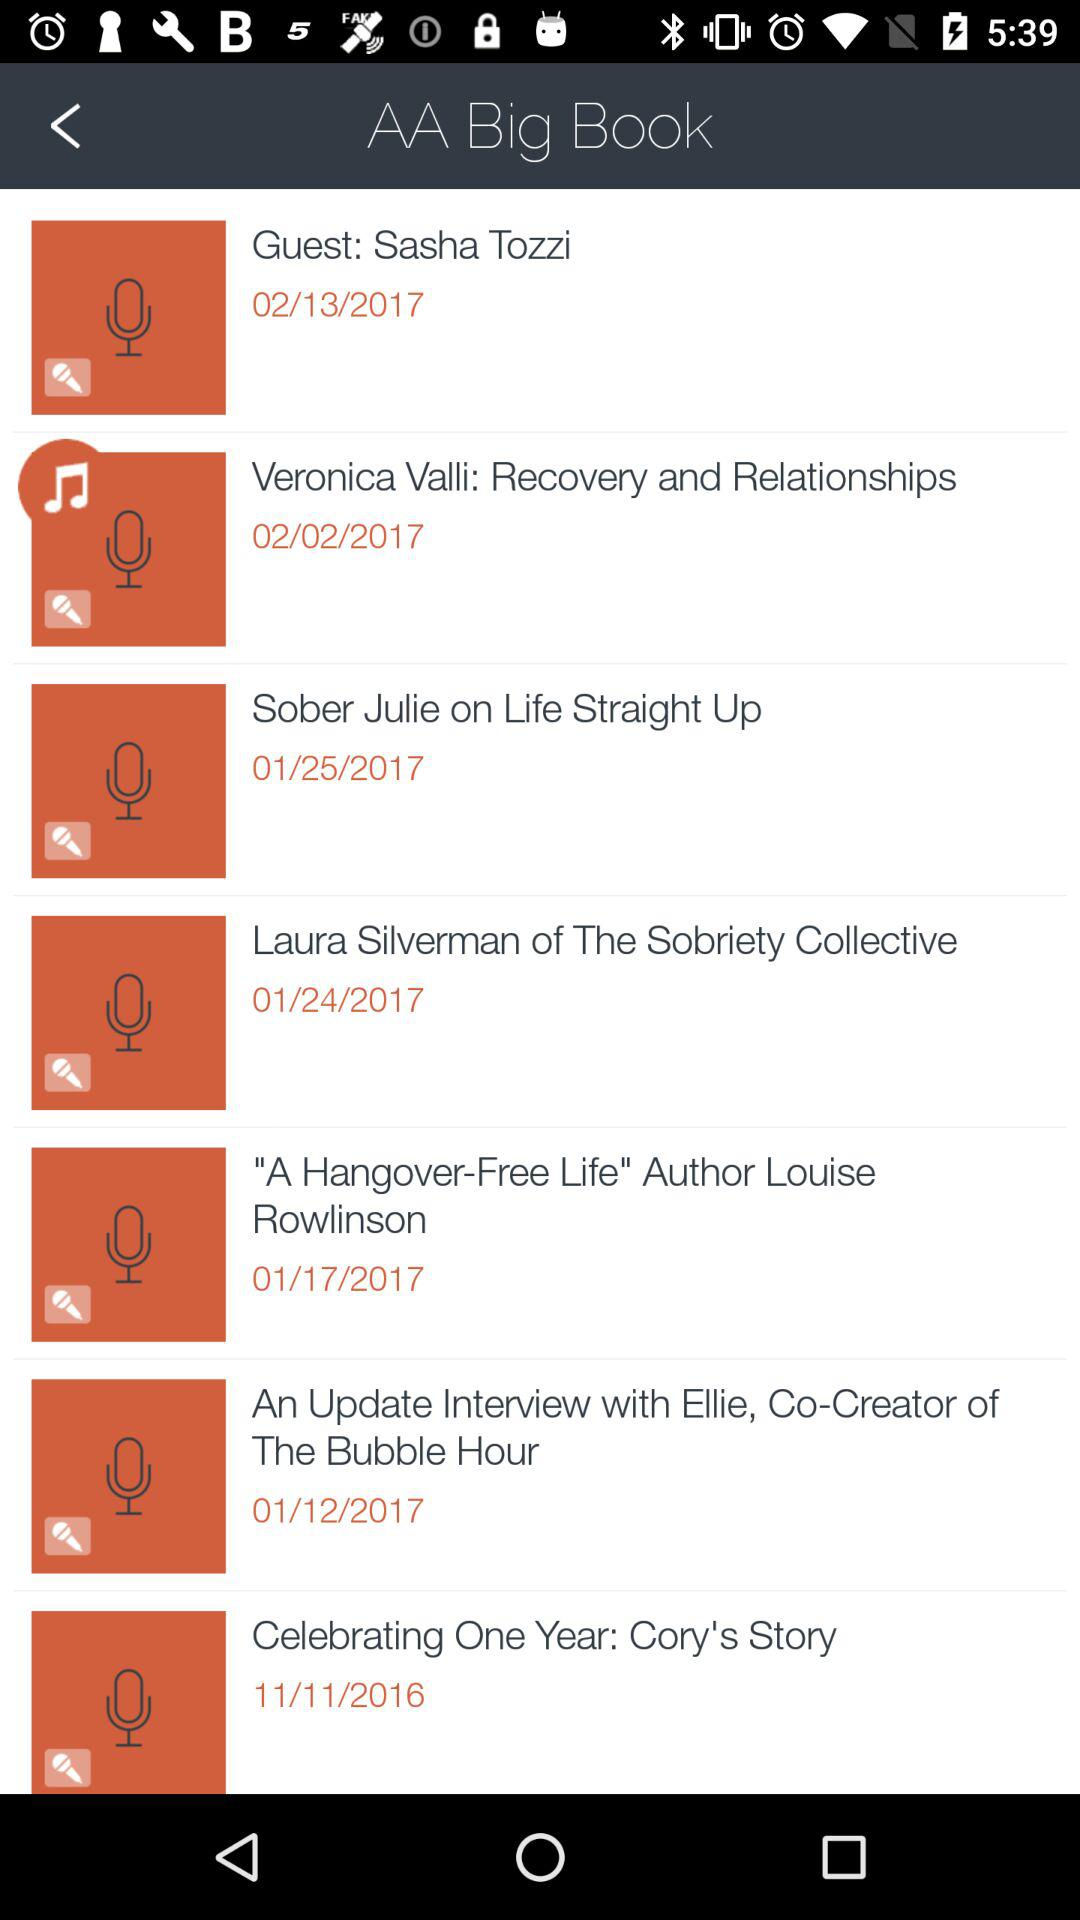Which date is mentioned for "Sober Julie on Life Straight Up"? The date mentioned for "Sober Julie on Life Straight Up" is January 25, 2017. 